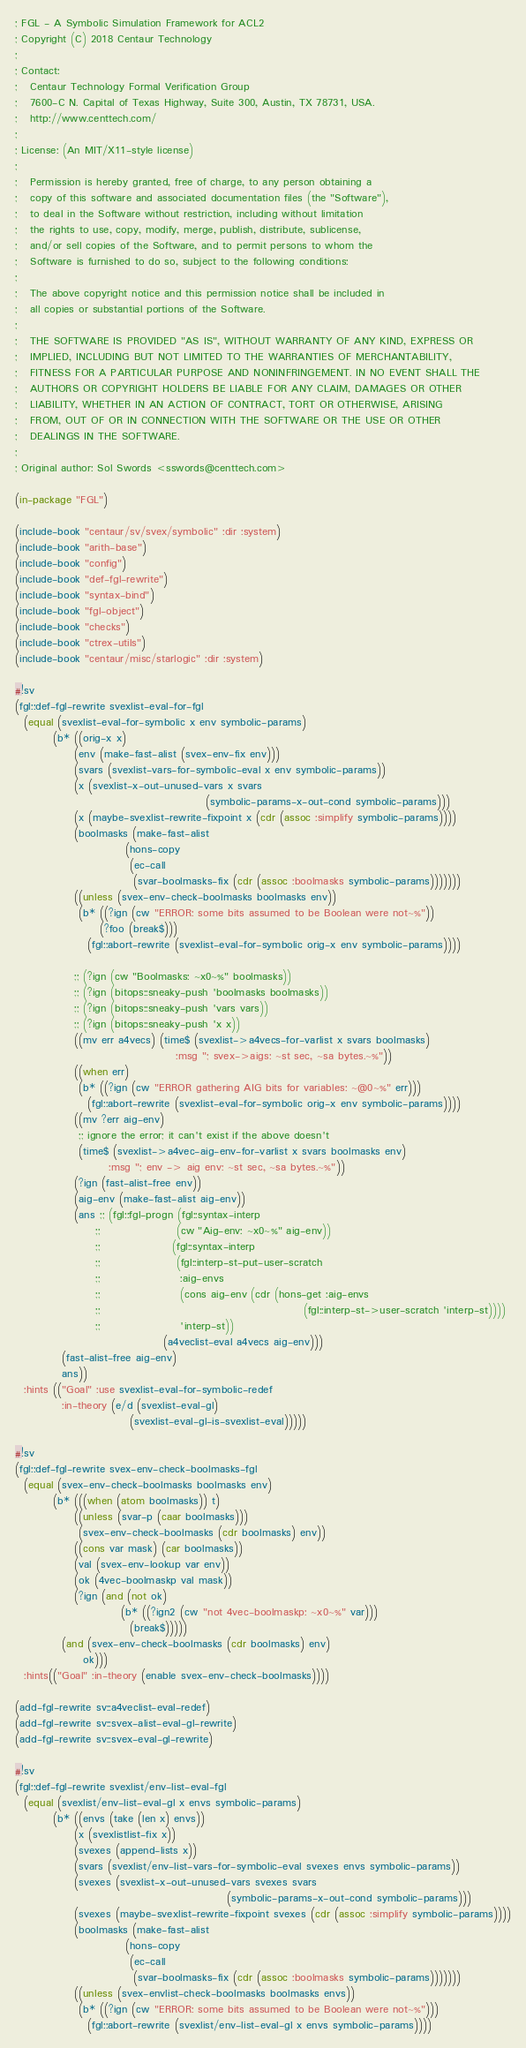<code> <loc_0><loc_0><loc_500><loc_500><_Lisp_>; FGL - A Symbolic Simulation Framework for ACL2
; Copyright (C) 2018 Centaur Technology
;
; Contact:
;   Centaur Technology Formal Verification Group
;   7600-C N. Capital of Texas Highway, Suite 300, Austin, TX 78731, USA.
;   http://www.centtech.com/
;
; License: (An MIT/X11-style license)
;
;   Permission is hereby granted, free of charge, to any person obtaining a
;   copy of this software and associated documentation files (the "Software"),
;   to deal in the Software without restriction, including without limitation
;   the rights to use, copy, modify, merge, publish, distribute, sublicense,
;   and/or sell copies of the Software, and to permit persons to whom the
;   Software is furnished to do so, subject to the following conditions:
;
;   The above copyright notice and this permission notice shall be included in
;   all copies or substantial portions of the Software.
;
;   THE SOFTWARE IS PROVIDED "AS IS", WITHOUT WARRANTY OF ANY KIND, EXPRESS OR
;   IMPLIED, INCLUDING BUT NOT LIMITED TO THE WARRANTIES OF MERCHANTABILITY,
;   FITNESS FOR A PARTICULAR PURPOSE AND NONINFRINGEMENT. IN NO EVENT SHALL THE
;   AUTHORS OR COPYRIGHT HOLDERS BE LIABLE FOR ANY CLAIM, DAMAGES OR OTHER
;   LIABILITY, WHETHER IN AN ACTION OF CONTRACT, TORT OR OTHERWISE, ARISING
;   FROM, OUT OF OR IN CONNECTION WITH THE SOFTWARE OR THE USE OR OTHER
;   DEALINGS IN THE SOFTWARE.
;
; Original author: Sol Swords <sswords@centtech.com>

(in-package "FGL")

(include-book "centaur/sv/svex/symbolic" :dir :system)
(include-book "arith-base")
(include-book "config")
(include-book "def-fgl-rewrite")
(include-book "syntax-bind")
(include-book "fgl-object")
(include-book "checks")
(include-book "ctrex-utils")
(include-book "centaur/misc/starlogic" :dir :system)

#!sv
(fgl::def-fgl-rewrite svexlist-eval-for-fgl
  (equal (svexlist-eval-for-symbolic x env symbolic-params)
         (b* ((orig-x x)
              (env (make-fast-alist (svex-env-fix env)))
              (svars (svexlist-vars-for-symbolic-eval x env symbolic-params))
              (x (svexlist-x-out-unused-vars x svars
                                             (symbolic-params-x-out-cond symbolic-params)))
              (x (maybe-svexlist-rewrite-fixpoint x (cdr (assoc :simplify symbolic-params))))
              (boolmasks (make-fast-alist
                          (hons-copy
                           (ec-call
                            (svar-boolmasks-fix (cdr (assoc :boolmasks symbolic-params)))))))
              ((unless (svex-env-check-boolmasks boolmasks env))
               (b* ((?ign (cw "ERROR: some bits assumed to be Boolean were not~%"))
                    (?foo (break$)))
                 (fgl::abort-rewrite (svexlist-eval-for-symbolic orig-x env symbolic-params))))

              ;; (?ign (cw "Boolmasks: ~x0~%" boolmasks))
              ;; (?ign (bitops::sneaky-push 'boolmasks boolmasks))
              ;; (?ign (bitops::sneaky-push 'vars vars))
              ;; (?ign (bitops::sneaky-push 'x x))
              ((mv err a4vecs) (time$ (svexlist->a4vecs-for-varlist x svars boolmasks)
                                      :msg "; svex->aigs: ~st sec, ~sa bytes.~%"))
              ((when err)
               (b* ((?ign (cw "ERROR gathering AIG bits for variables: ~@0~%" err)))
                 (fgl::abort-rewrite (svexlist-eval-for-symbolic orig-x env symbolic-params))))
              ((mv ?err aig-env)
               ;; ignore the error; it can't exist if the above doesn't
               (time$ (svexlist->a4vec-aig-env-for-varlist x svars boolmasks env)
                      :msg "; env -> aig env: ~st sec, ~sa bytes.~%"))
              (?ign (fast-alist-free env))
              (aig-env (make-fast-alist aig-env))
              (ans ;; (fgl::fgl-progn (fgl::syntax-interp
                   ;;                  (cw "Aig-env: ~x0~%" aig-env))
                   ;;                 (fgl::syntax-interp
                   ;;                  (fgl::interp-st-put-user-scratch
                   ;;                   :aig-envs
                   ;;                   (cons aig-env (cdr (hons-get :aig-envs
                   ;;                                                (fgl::interp-st->user-scratch 'interp-st))))
                   ;;                   'interp-st))
                                   (a4veclist-eval a4vecs aig-env)))
           (fast-alist-free aig-env)
           ans))
  :hints (("Goal" :use svexlist-eval-for-symbolic-redef
           :in-theory (e/d (svexlist-eval-gl)
                           (svexlist-eval-gl-is-svexlist-eval)))))

#!sv
(fgl::def-fgl-rewrite svex-env-check-boolmasks-fgl
  (equal (svex-env-check-boolmasks boolmasks env)
         (b* (((when (atom boolmasks)) t)
              ((unless (svar-p (caar boolmasks)))
               (svex-env-check-boolmasks (cdr boolmasks) env))
              ((cons var mask) (car boolmasks))
              (val (svex-env-lookup var env))
              (ok (4vec-boolmaskp val mask))
              (?ign (and (not ok)
                         (b* ((?ign2 (cw "not 4vec-boolmaskp: ~x0~%" var)))
                           (break$)))))
           (and (svex-env-check-boolmasks (cdr boolmasks) env)
                ok)))
  :hints(("Goal" :in-theory (enable svex-env-check-boolmasks))))

(add-fgl-rewrite sv::a4veclist-eval-redef)
(add-fgl-rewrite sv::svex-alist-eval-gl-rewrite)
(add-fgl-rewrite sv::svex-eval-gl-rewrite)

#!sv
(fgl::def-fgl-rewrite svexlist/env-list-eval-fgl
  (equal (svexlist/env-list-eval-gl x envs symbolic-params)
         (b* ((envs (take (len x) envs))
              (x (svexlistlist-fix x))
              (svexes (append-lists x))
              (svars (svexlist/env-list-vars-for-symbolic-eval svexes envs symbolic-params))
              (svexes (svexlist-x-out-unused-vars svexes svars
                                                  (symbolic-params-x-out-cond symbolic-params)))
              (svexes (maybe-svexlist-rewrite-fixpoint svexes (cdr (assoc :simplify symbolic-params))))
              (boolmasks (make-fast-alist
                          (hons-copy
                           (ec-call
                            (svar-boolmasks-fix (cdr (assoc :boolmasks symbolic-params)))))))
              ((unless (svex-envlist-check-boolmasks boolmasks envs))
               (b* ((?ign (cw "ERROR: some bits assumed to be Boolean were not~%")))
                 (fgl::abort-rewrite (svexlist/env-list-eval-gl x envs symbolic-params))))</code> 